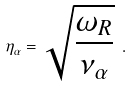Convert formula to latex. <formula><loc_0><loc_0><loc_500><loc_500>\eta _ { \alpha } = \sqrt { \frac { \omega _ { R } } { \nu _ { \alpha } } } \ .</formula> 